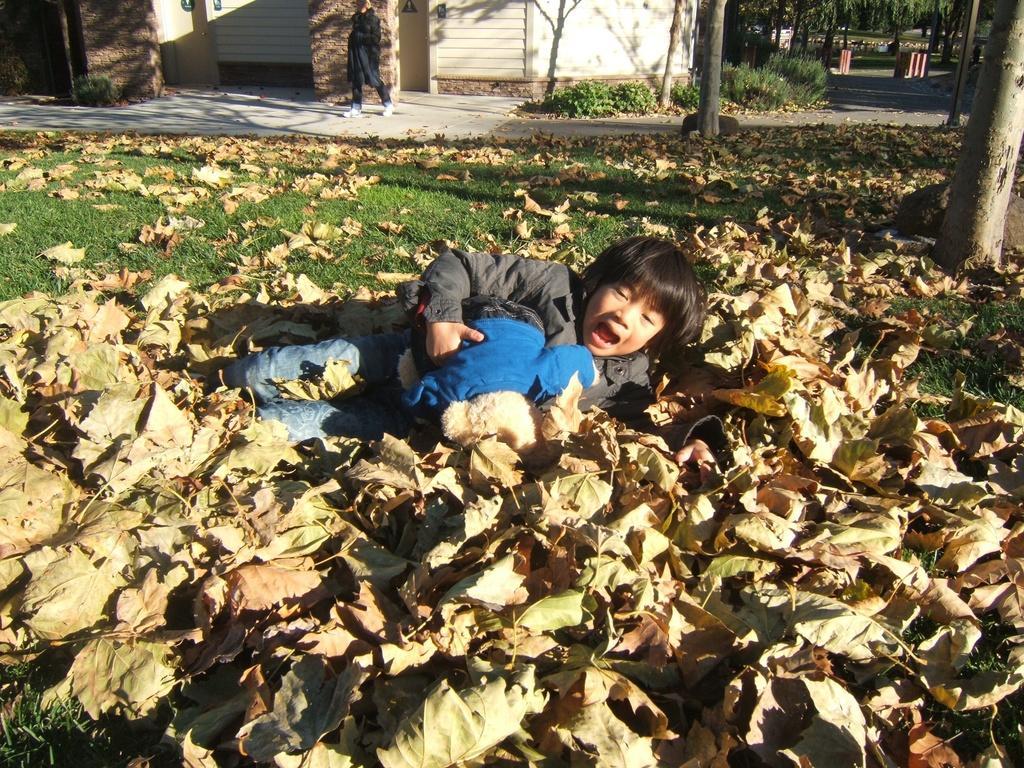Can you describe this image briefly? In this image, we can see grass on the ground, there are some dried leaves on the ground, it looks like a kid fallen on the leaves, we can see a person walking in the background, we can see shutters and a wall, there are some trees. 